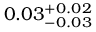Convert formula to latex. <formula><loc_0><loc_0><loc_500><loc_500>0 . 0 3 _ { - 0 . 0 3 } ^ { + 0 . 0 2 }</formula> 